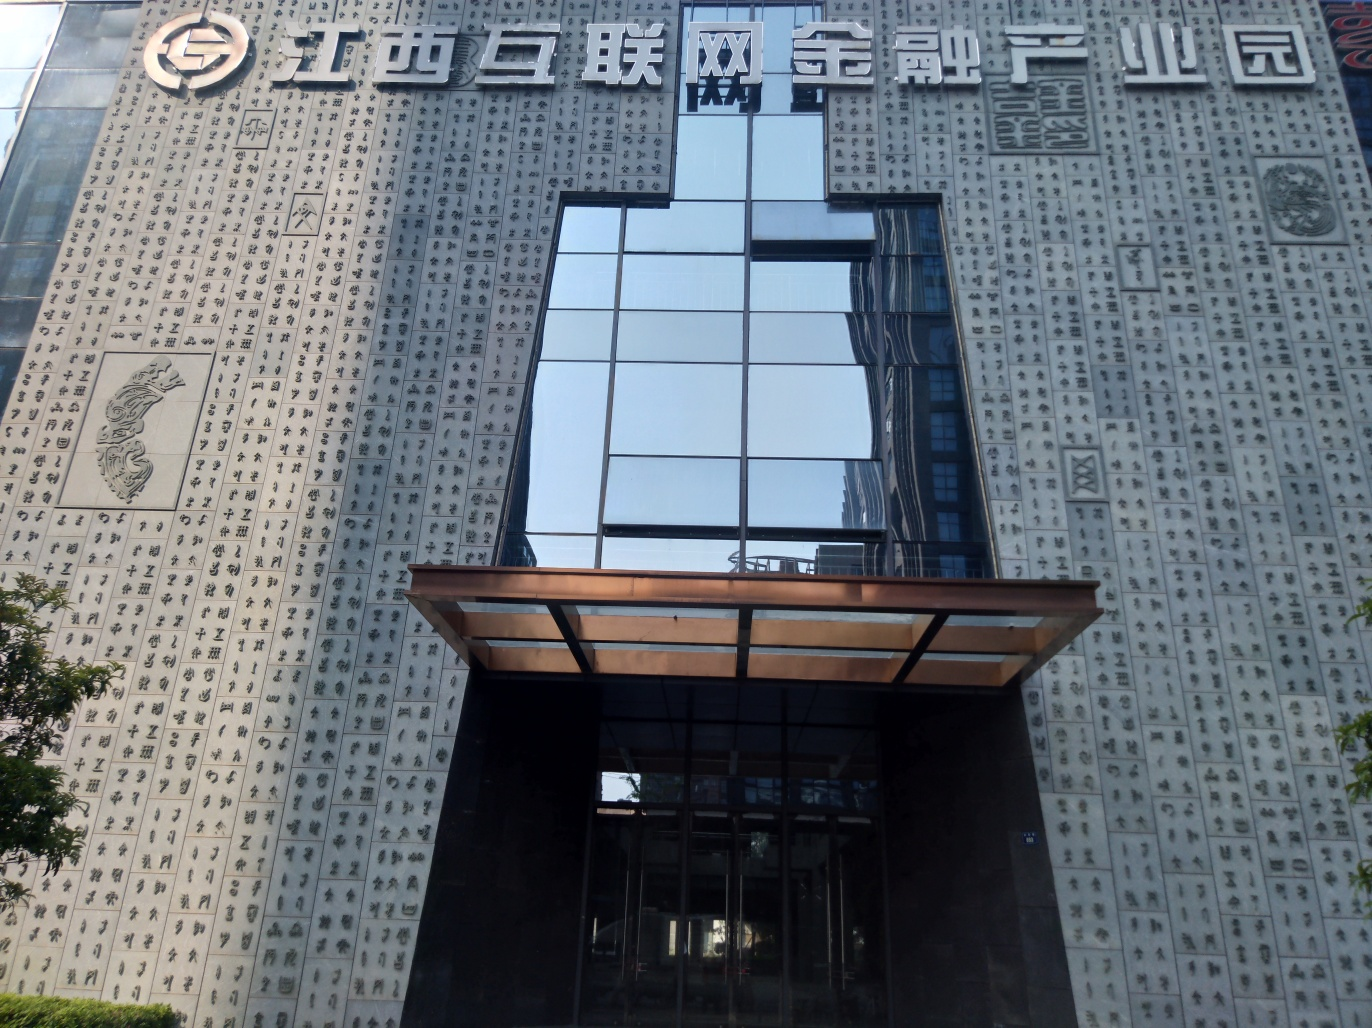Can the details on the walls be distinguished? Indeed, the wall details are clearly visible. The building's facade is adorned with numerous Chinese characters of varying styles, presenting a canvas of cultural significance and artistic expression. 